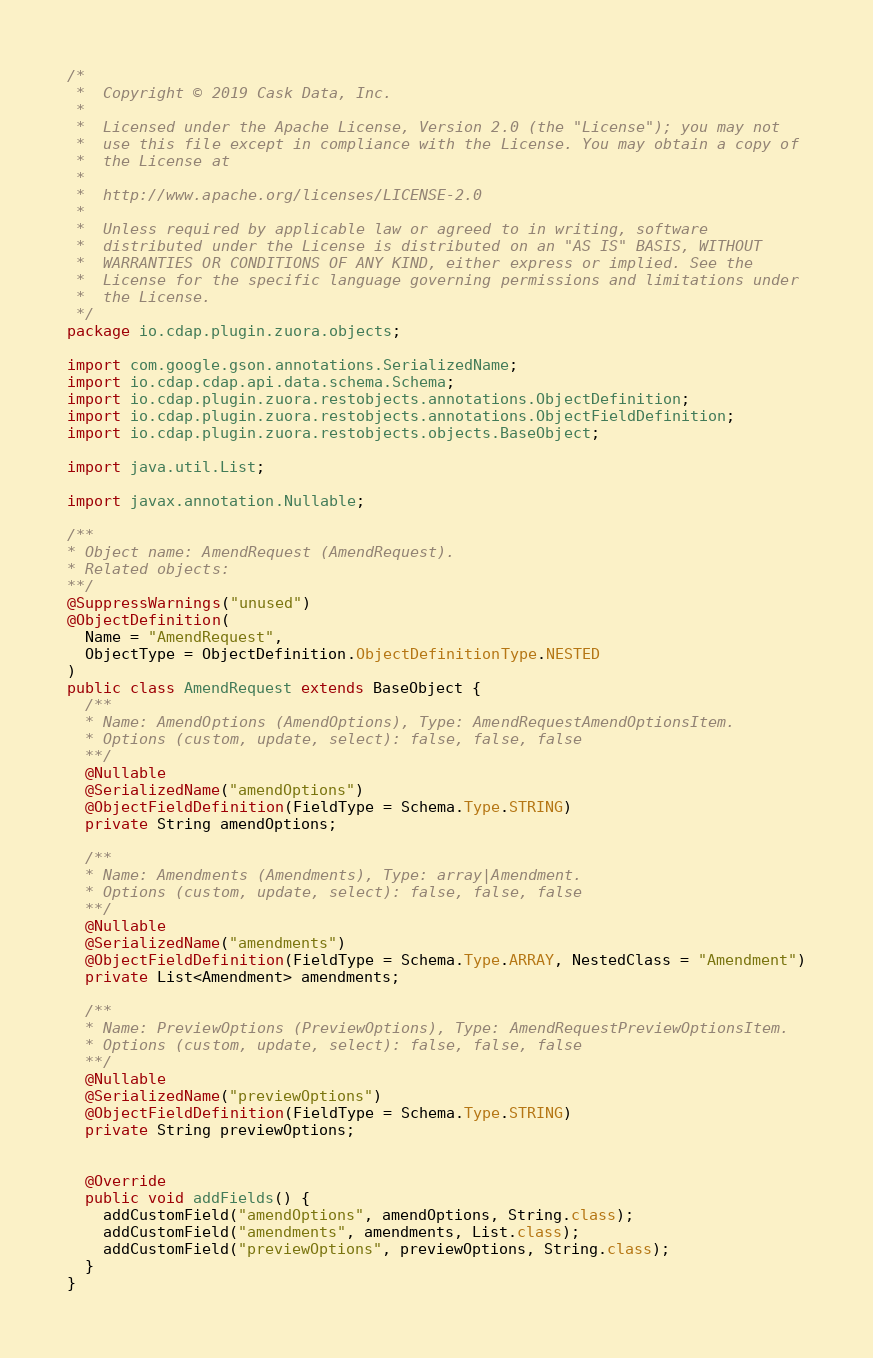Convert code to text. <code><loc_0><loc_0><loc_500><loc_500><_Java_>/*
 *  Copyright © 2019 Cask Data, Inc.
 *
 *  Licensed under the Apache License, Version 2.0 (the "License"); you may not
 *  use this file except in compliance with the License. You may obtain a copy of
 *  the License at
 *
 *  http://www.apache.org/licenses/LICENSE-2.0
 *
 *  Unless required by applicable law or agreed to in writing, software
 *  distributed under the License is distributed on an "AS IS" BASIS, WITHOUT
 *  WARRANTIES OR CONDITIONS OF ANY KIND, either express or implied. See the
 *  License for the specific language governing permissions and limitations under
 *  the License.
 */
package io.cdap.plugin.zuora.objects;

import com.google.gson.annotations.SerializedName;
import io.cdap.cdap.api.data.schema.Schema;
import io.cdap.plugin.zuora.restobjects.annotations.ObjectDefinition;
import io.cdap.plugin.zuora.restobjects.annotations.ObjectFieldDefinition;
import io.cdap.plugin.zuora.restobjects.objects.BaseObject;

import java.util.List;

import javax.annotation.Nullable;

/**
* Object name: AmendRequest (AmendRequest).
* Related objects:
**/
@SuppressWarnings("unused")
@ObjectDefinition(
  Name = "AmendRequest",
  ObjectType = ObjectDefinition.ObjectDefinitionType.NESTED
)
public class AmendRequest extends BaseObject {
  /**
  * Name: AmendOptions (AmendOptions), Type: AmendRequestAmendOptionsItem.
  * Options (custom, update, select): false, false, false
  **/
  @Nullable
  @SerializedName("amendOptions")
  @ObjectFieldDefinition(FieldType = Schema.Type.STRING)
  private String amendOptions;

  /**
  * Name: Amendments (Amendments), Type: array|Amendment.
  * Options (custom, update, select): false, false, false
  **/
  @Nullable
  @SerializedName("amendments")
  @ObjectFieldDefinition(FieldType = Schema.Type.ARRAY, NestedClass = "Amendment")
  private List<Amendment> amendments;

  /**
  * Name: PreviewOptions (PreviewOptions), Type: AmendRequestPreviewOptionsItem.
  * Options (custom, update, select): false, false, false
  **/
  @Nullable
  @SerializedName("previewOptions")
  @ObjectFieldDefinition(FieldType = Schema.Type.STRING)
  private String previewOptions;


  @Override
  public void addFields() {
    addCustomField("amendOptions", amendOptions, String.class);
    addCustomField("amendments", amendments, List.class);
    addCustomField("previewOptions", previewOptions, String.class);
  }
}
</code> 